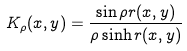<formula> <loc_0><loc_0><loc_500><loc_500>K _ { \rho } ( x , y ) = \frac { \sin \rho r ( x , y ) } { \rho \sinh r ( x , y ) }</formula> 